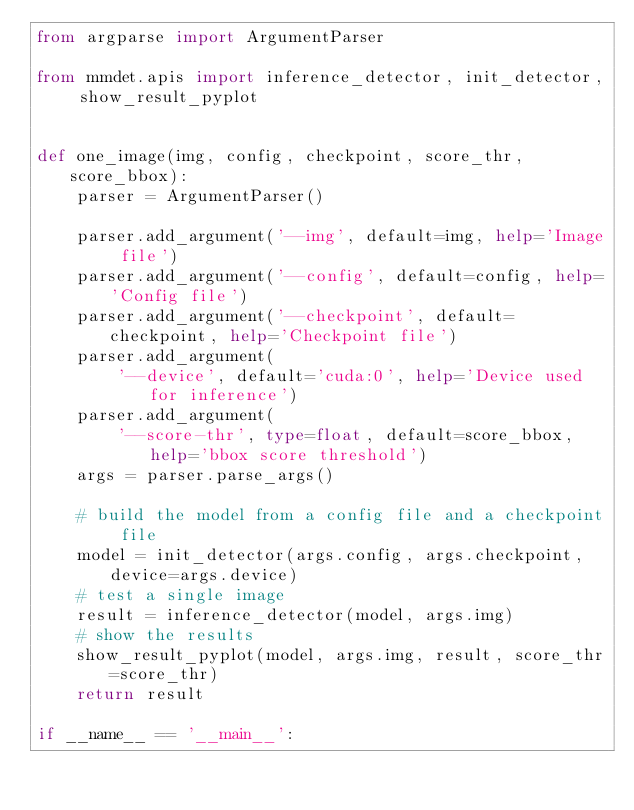Convert code to text. <code><loc_0><loc_0><loc_500><loc_500><_Python_>from argparse import ArgumentParser

from mmdet.apis import inference_detector, init_detector, show_result_pyplot


def one_image(img, config, checkpoint, score_thr, score_bbox):
    parser = ArgumentParser()

    parser.add_argument('--img', default=img, help='Image file')
    parser.add_argument('--config', default=config, help='Config file')
    parser.add_argument('--checkpoint', default=checkpoint, help='Checkpoint file')
    parser.add_argument(
        '--device', default='cuda:0', help='Device used for inference')
    parser.add_argument(
        '--score-thr', type=float, default=score_bbox, help='bbox score threshold')
    args = parser.parse_args()

    # build the model from a config file and a checkpoint file
    model = init_detector(args.config, args.checkpoint, device=args.device)
    # test a single image
    result = inference_detector(model, args.img)
    # show the results
    show_result_pyplot(model, args.img, result, score_thr=score_thr)
    return result

if __name__ == '__main__':</code> 